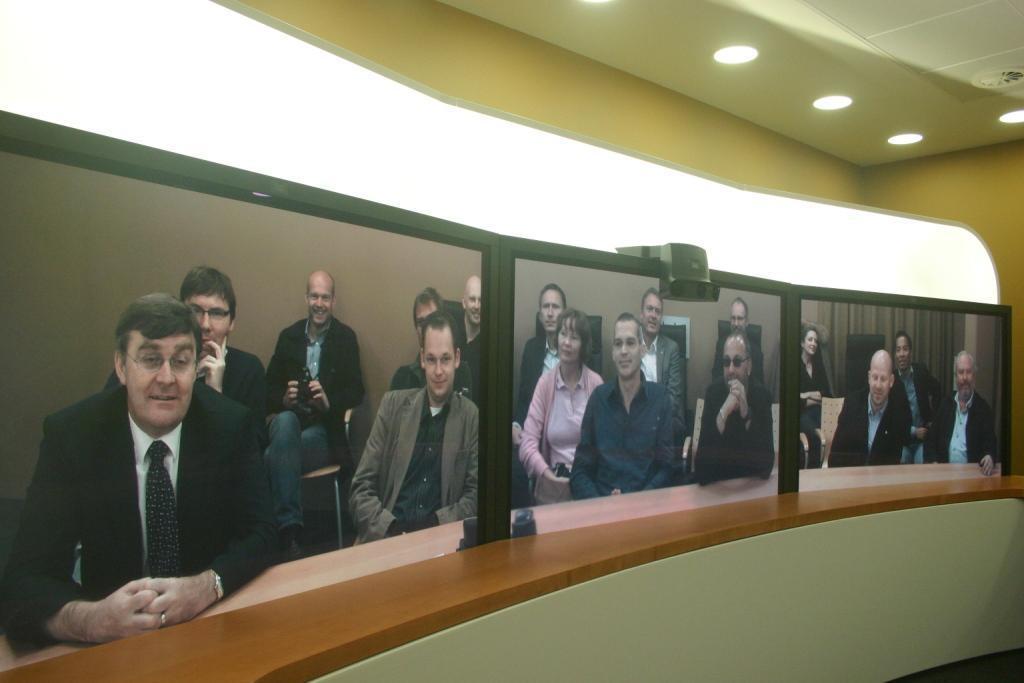How would you summarize this image in a sentence or two? In this image there are people sitting on the chairs. Behind them there is a wall, curtain and a few other objects. In front of them there is a glass. On top of the glass there is some object. There is a wooden platform. On top of the image there are lights. 